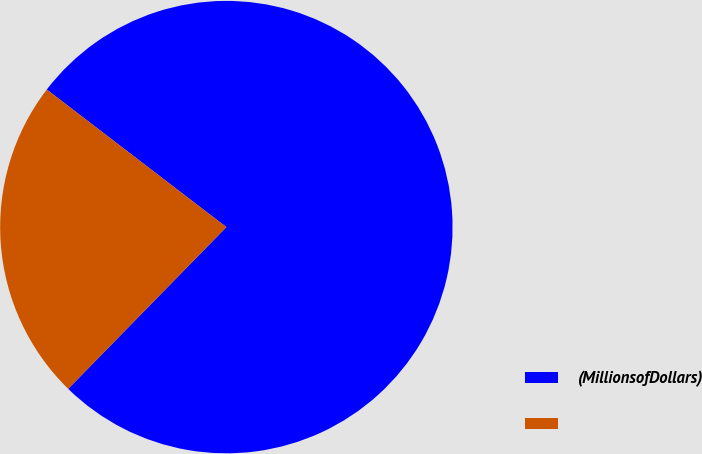Convert chart. <chart><loc_0><loc_0><loc_500><loc_500><pie_chart><fcel>(MillionsofDollars)<fcel>Unnamed: 1<nl><fcel>76.92%<fcel>23.08%<nl></chart> 